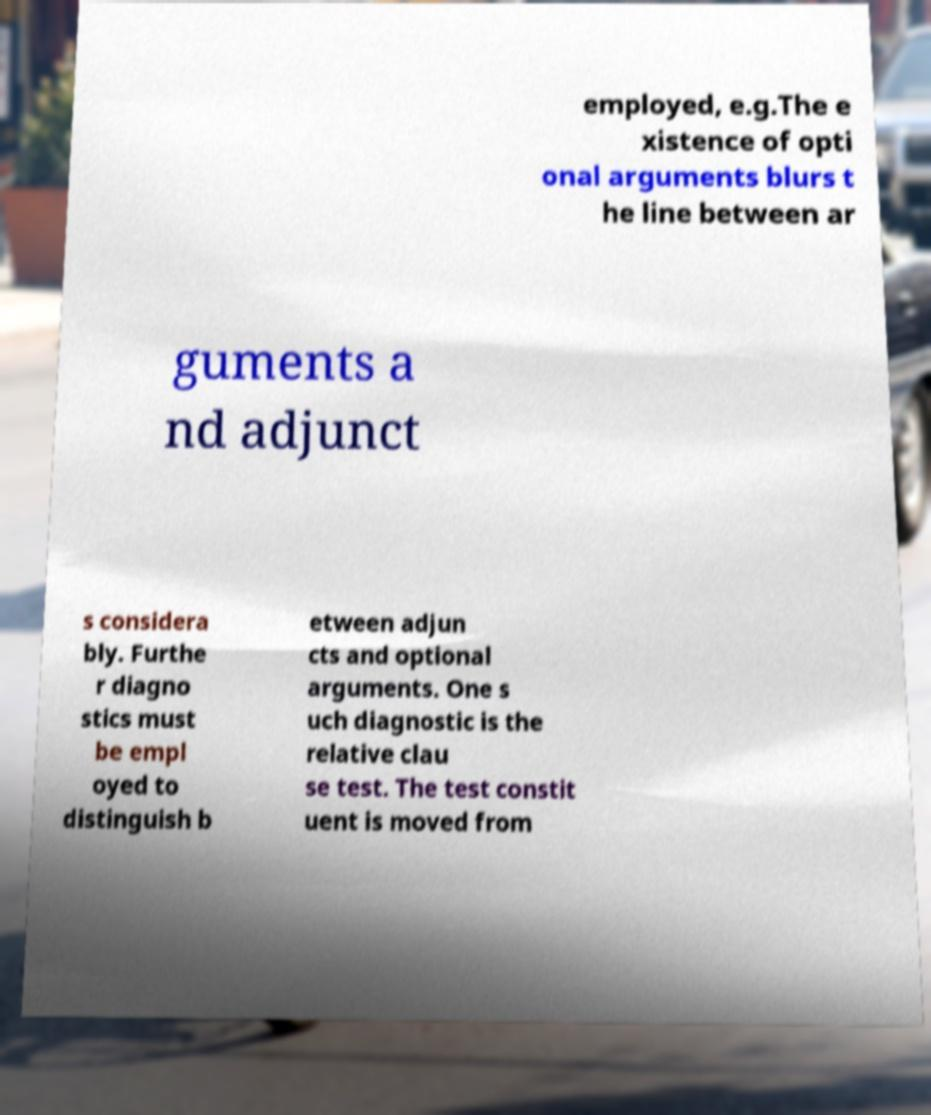I need the written content from this picture converted into text. Can you do that? employed, e.g.The e xistence of opti onal arguments blurs t he line between ar guments a nd adjunct s considera bly. Furthe r diagno stics must be empl oyed to distinguish b etween adjun cts and optional arguments. One s uch diagnostic is the relative clau se test. The test constit uent is moved from 